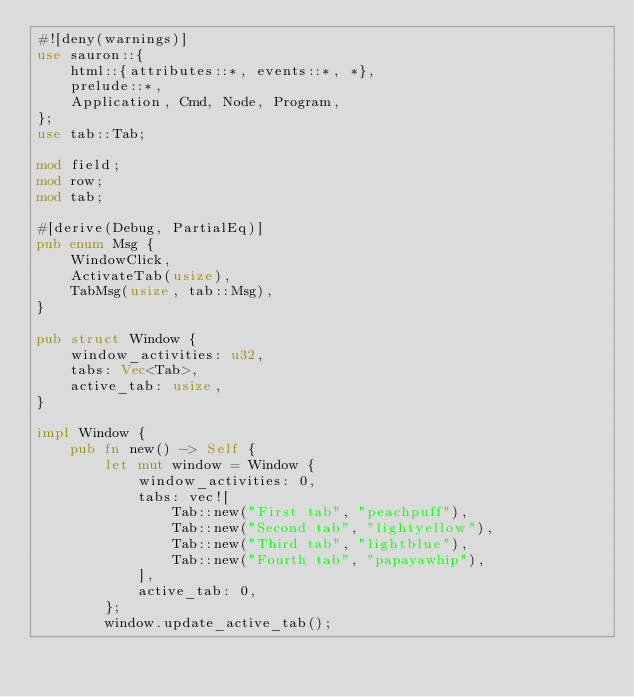<code> <loc_0><loc_0><loc_500><loc_500><_Rust_>#![deny(warnings)]
use sauron::{
    html::{attributes::*, events::*, *},
    prelude::*,
    Application, Cmd, Node, Program,
};
use tab::Tab;

mod field;
mod row;
mod tab;

#[derive(Debug, PartialEq)]
pub enum Msg {
    WindowClick,
    ActivateTab(usize),
    TabMsg(usize, tab::Msg),
}

pub struct Window {
    window_activities: u32,
    tabs: Vec<Tab>,
    active_tab: usize,
}

impl Window {
    pub fn new() -> Self {
        let mut window = Window {
            window_activities: 0,
            tabs: vec![
                Tab::new("First tab", "peachpuff"),
                Tab::new("Second tab", "lightyellow"),
                Tab::new("Third tab", "lightblue"),
                Tab::new("Fourth tab", "papayawhip"),
            ],
            active_tab: 0,
        };
        window.update_active_tab();</code> 